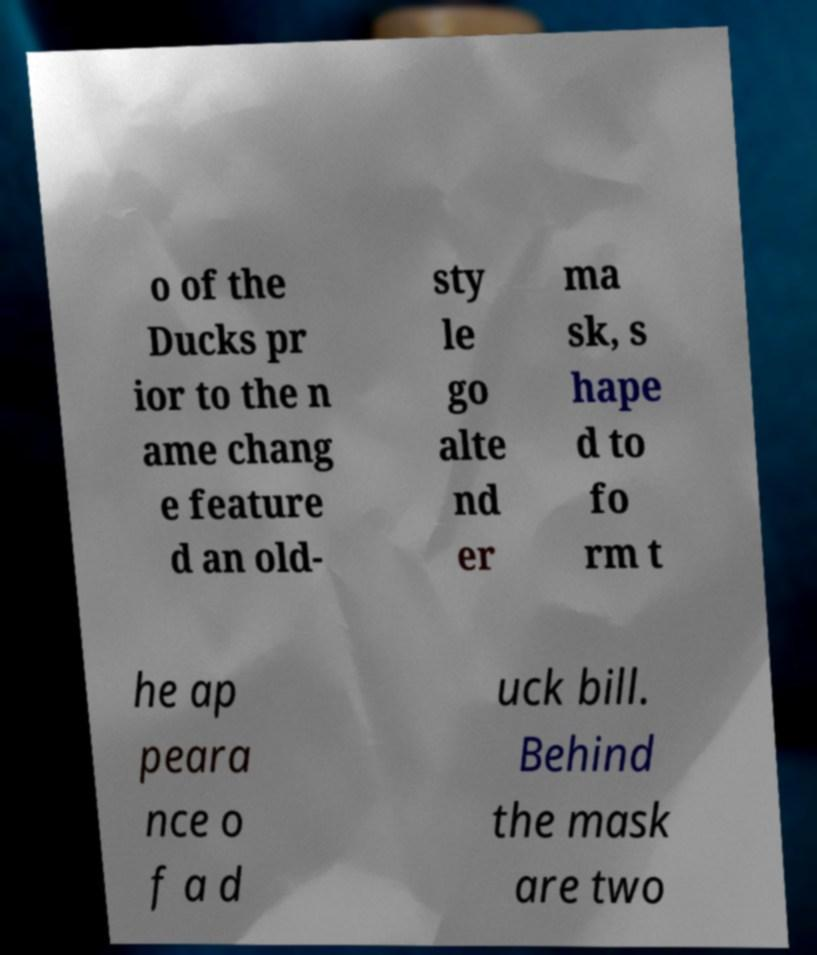Can you accurately transcribe the text from the provided image for me? o of the Ducks pr ior to the n ame chang e feature d an old- sty le go alte nd er ma sk, s hape d to fo rm t he ap peara nce o f a d uck bill. Behind the mask are two 